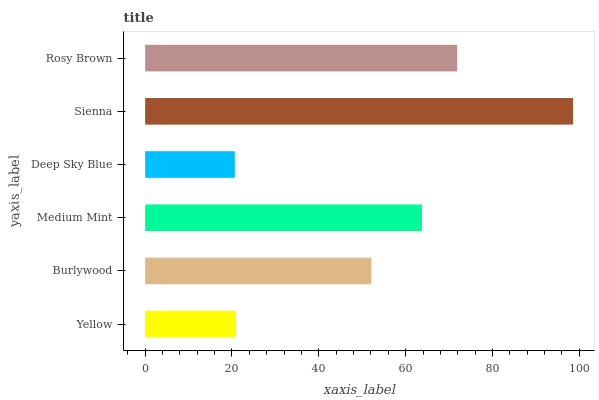Is Deep Sky Blue the minimum?
Answer yes or no. Yes. Is Sienna the maximum?
Answer yes or no. Yes. Is Burlywood the minimum?
Answer yes or no. No. Is Burlywood the maximum?
Answer yes or no. No. Is Burlywood greater than Yellow?
Answer yes or no. Yes. Is Yellow less than Burlywood?
Answer yes or no. Yes. Is Yellow greater than Burlywood?
Answer yes or no. No. Is Burlywood less than Yellow?
Answer yes or no. No. Is Medium Mint the high median?
Answer yes or no. Yes. Is Burlywood the low median?
Answer yes or no. Yes. Is Sienna the high median?
Answer yes or no. No. Is Deep Sky Blue the low median?
Answer yes or no. No. 